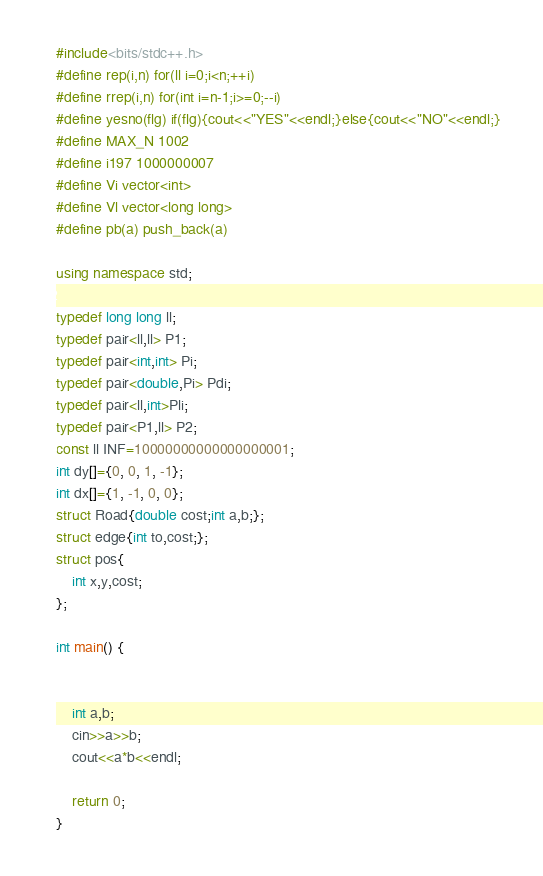Convert code to text. <code><loc_0><loc_0><loc_500><loc_500><_C++_>#include<bits/stdc++.h>
#define rep(i,n) for(ll i=0;i<n;++i)
#define rrep(i,n) for(int i=n-1;i>=0;--i)
#define yesno(flg) if(flg){cout<<"YES"<<endl;}else{cout<<"NO"<<endl;}
#define MAX_N 1002
#define i197 1000000007
#define Vi vector<int>
#define Vl vector<long long>
#define pb(a) push_back(a)

using namespace std;

typedef long long ll;
typedef pair<ll,ll> P1;
typedef pair<int,int> Pi;
typedef pair<double,Pi> Pdi;
typedef pair<ll,int>Pli;
typedef pair<P1,ll> P2;
const ll INF=10000000000000000001;
int dy[]={0, 0, 1, -1};
int dx[]={1, -1, 0, 0};
struct Road{double cost;int a,b;};
struct edge{int to,cost;};
struct pos{
	int x,y,cost;
};

int main() {


	int a,b;
	cin>>a>>b;
	cout<<a*b<<endl;

	return 0;
}
</code> 